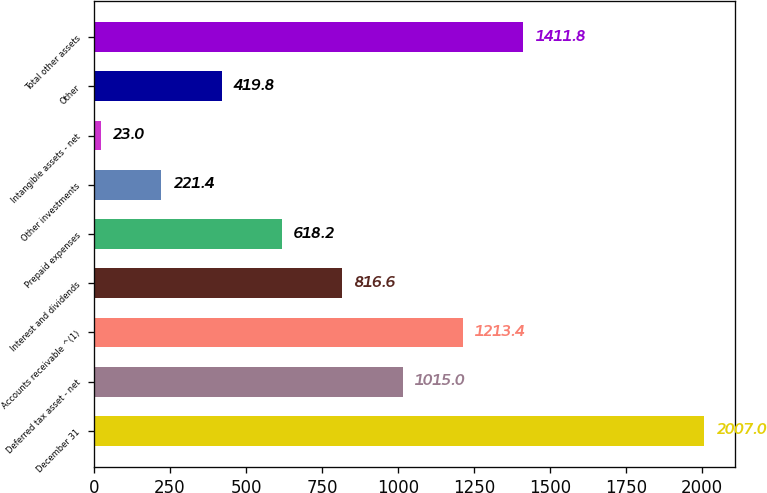Convert chart to OTSL. <chart><loc_0><loc_0><loc_500><loc_500><bar_chart><fcel>December 31<fcel>Deferred tax asset - net<fcel>Accounts receivable ^(1)<fcel>Interest and dividends<fcel>Prepaid expenses<fcel>Other investments<fcel>Intangible assets - net<fcel>Other<fcel>Total other assets<nl><fcel>2007<fcel>1015<fcel>1213.4<fcel>816.6<fcel>618.2<fcel>221.4<fcel>23<fcel>419.8<fcel>1411.8<nl></chart> 